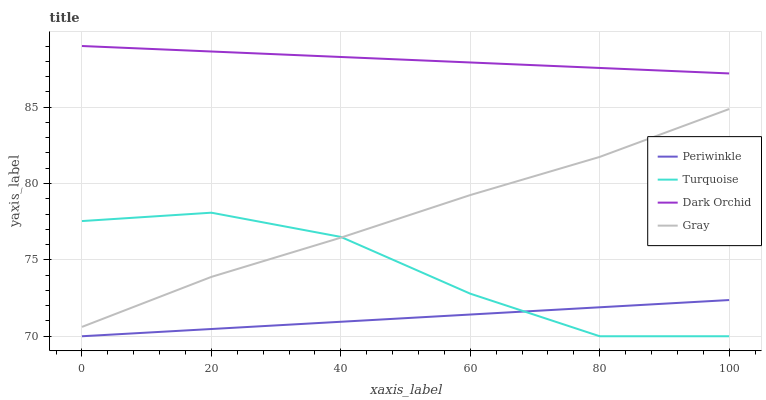Does Periwinkle have the minimum area under the curve?
Answer yes or no. Yes. Does Dark Orchid have the maximum area under the curve?
Answer yes or no. Yes. Does Turquoise have the minimum area under the curve?
Answer yes or no. No. Does Turquoise have the maximum area under the curve?
Answer yes or no. No. Is Periwinkle the smoothest?
Answer yes or no. Yes. Is Turquoise the roughest?
Answer yes or no. Yes. Is Turquoise the smoothest?
Answer yes or no. No. Is Periwinkle the roughest?
Answer yes or no. No. Does Turquoise have the lowest value?
Answer yes or no. Yes. Does Dark Orchid have the lowest value?
Answer yes or no. No. Does Dark Orchid have the highest value?
Answer yes or no. Yes. Does Turquoise have the highest value?
Answer yes or no. No. Is Turquoise less than Dark Orchid?
Answer yes or no. Yes. Is Dark Orchid greater than Periwinkle?
Answer yes or no. Yes. Does Gray intersect Turquoise?
Answer yes or no. Yes. Is Gray less than Turquoise?
Answer yes or no. No. Is Gray greater than Turquoise?
Answer yes or no. No. Does Turquoise intersect Dark Orchid?
Answer yes or no. No. 